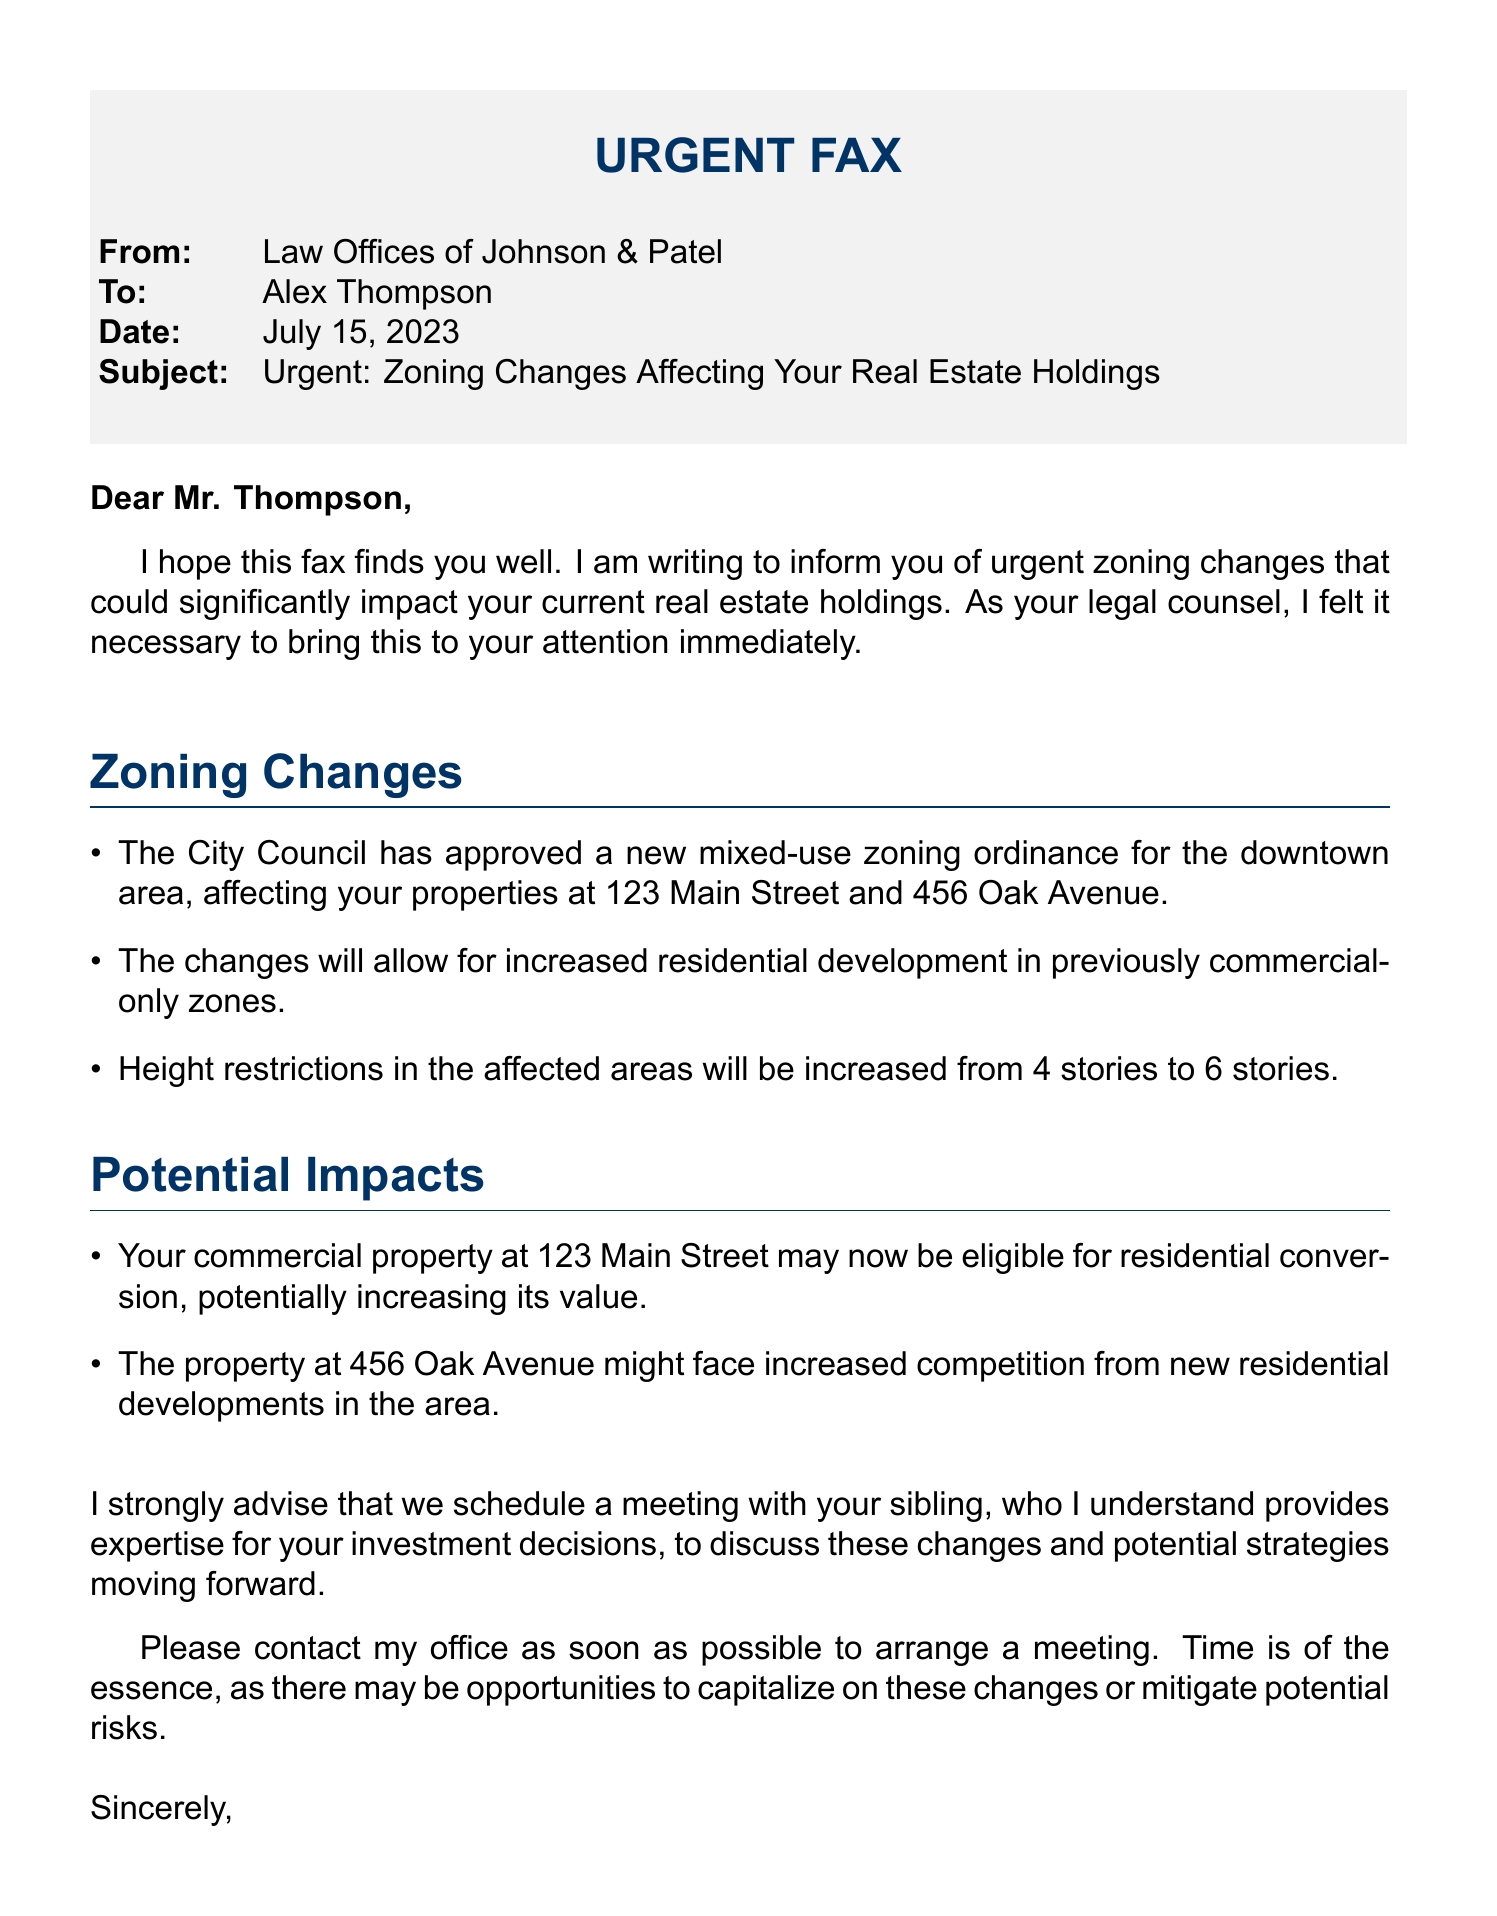What is the date of the fax? The date of the fax is specifically mentioned in the document under the Date section.
Answer: July 15, 2023 Who is the sender of the fax? The sender is listed in the From section of the document.
Answer: Law Offices of Johnson & Patel What is the subject of the fax? The subject is clearly stated at the top of the document, under the Subject section.
Answer: Urgent: Zoning Changes Affecting Your Real Estate Holdings Which properties are affected by the zoning changes? The properties are listed in the Zoning Changes section of the fax.
Answer: 123 Main Street and 456 Oak Avenue What is the new height restriction for the affected areas? This information is provided in the Zoning Changes section regarding height restrictions.
Answer: 6 stories What potential benefit is mentioned for the property at 123 Main Street? The benefit is outlined in the Potential Impacts section of the document.
Answer: Eligibility for residential conversion Why is it important to contact the lawyer quickly? The urgency is expressed in the closing remarks emphasizing timely action.
Answer: Time is of the essence Who should be included in the meeting to discuss these changes? The document suggests someone who has expertise in investment decisions.
Answer: Sibling What legal title does Sarah Johnson hold? This is indicated at the end of the document under her name.
Answer: Esq 